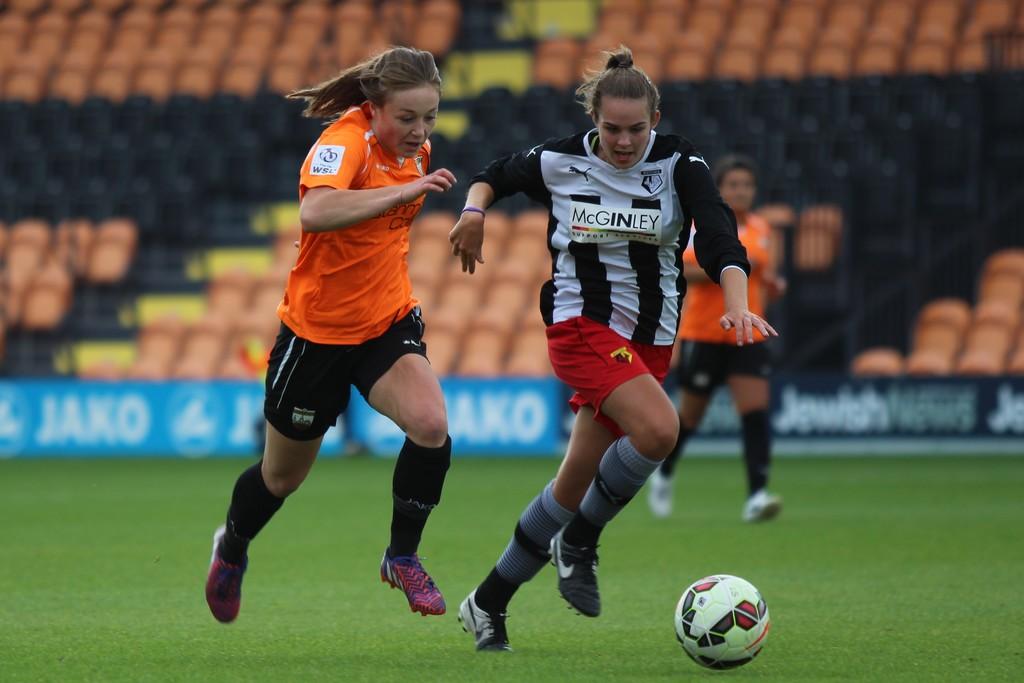Which team is the one wearing stripes?
Provide a succinct answer. Mcginley. 